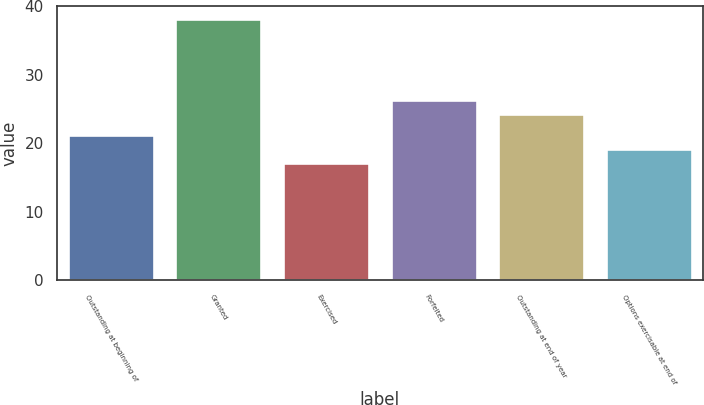Convert chart to OTSL. <chart><loc_0><loc_0><loc_500><loc_500><bar_chart><fcel>Outstanding at beginning of<fcel>Granted<fcel>Exercised<fcel>Forfeited<fcel>Outstanding at end of year<fcel>Options exercisable at end of<nl><fcel>21.28<fcel>38.17<fcel>17.06<fcel>26.37<fcel>24.26<fcel>19.17<nl></chart> 